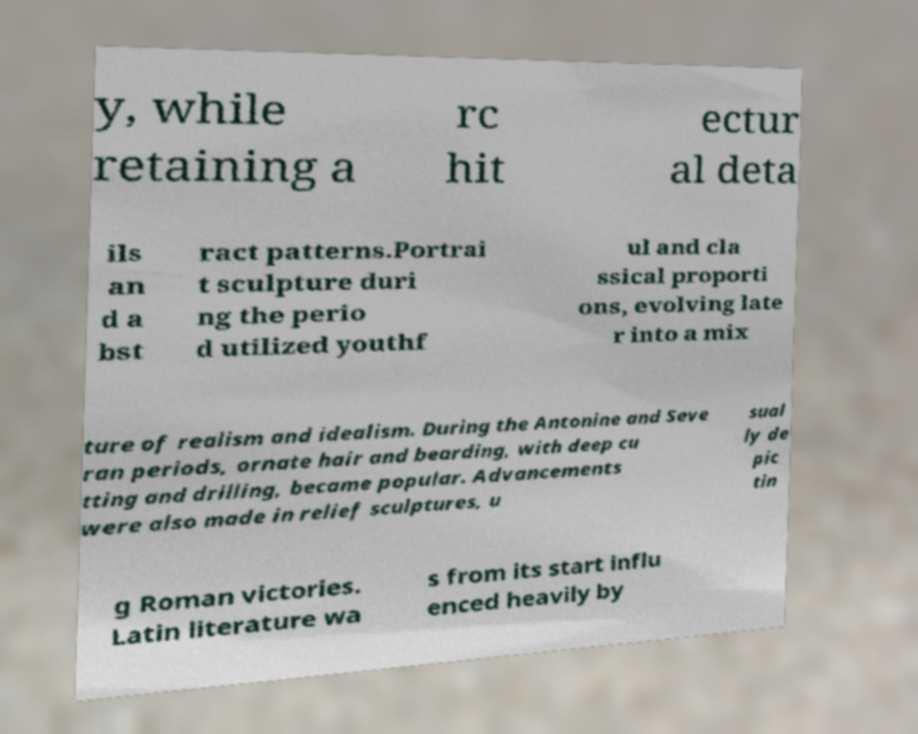What messages or text are displayed in this image? I need them in a readable, typed format. y, while retaining a rc hit ectur al deta ils an d a bst ract patterns.Portrai t sculpture duri ng the perio d utilized youthf ul and cla ssical proporti ons, evolving late r into a mix ture of realism and idealism. During the Antonine and Seve ran periods, ornate hair and bearding, with deep cu tting and drilling, became popular. Advancements were also made in relief sculptures, u sual ly de pic tin g Roman victories. Latin literature wa s from its start influ enced heavily by 